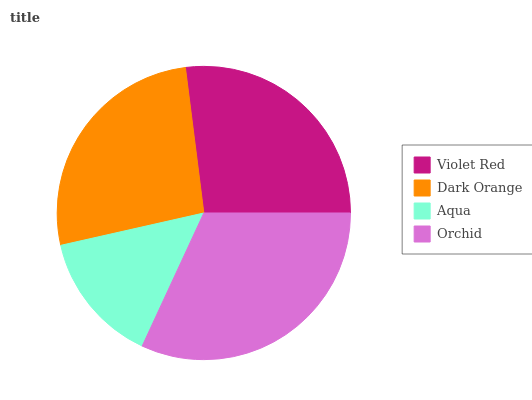Is Aqua the minimum?
Answer yes or no. Yes. Is Orchid the maximum?
Answer yes or no. Yes. Is Dark Orange the minimum?
Answer yes or no. No. Is Dark Orange the maximum?
Answer yes or no. No. Is Violet Red greater than Dark Orange?
Answer yes or no. Yes. Is Dark Orange less than Violet Red?
Answer yes or no. Yes. Is Dark Orange greater than Violet Red?
Answer yes or no. No. Is Violet Red less than Dark Orange?
Answer yes or no. No. Is Violet Red the high median?
Answer yes or no. Yes. Is Dark Orange the low median?
Answer yes or no. Yes. Is Aqua the high median?
Answer yes or no. No. Is Orchid the low median?
Answer yes or no. No. 